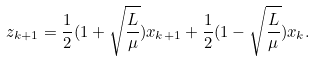Convert formula to latex. <formula><loc_0><loc_0><loc_500><loc_500>z _ { k + 1 } = \frac { 1 } { 2 } ( 1 + \sqrt { \frac { L } { \mu } } ) x _ { k + 1 } + \frac { 1 } { 2 } ( 1 - \sqrt { \frac { L } { \mu } } ) x _ { k } .</formula> 